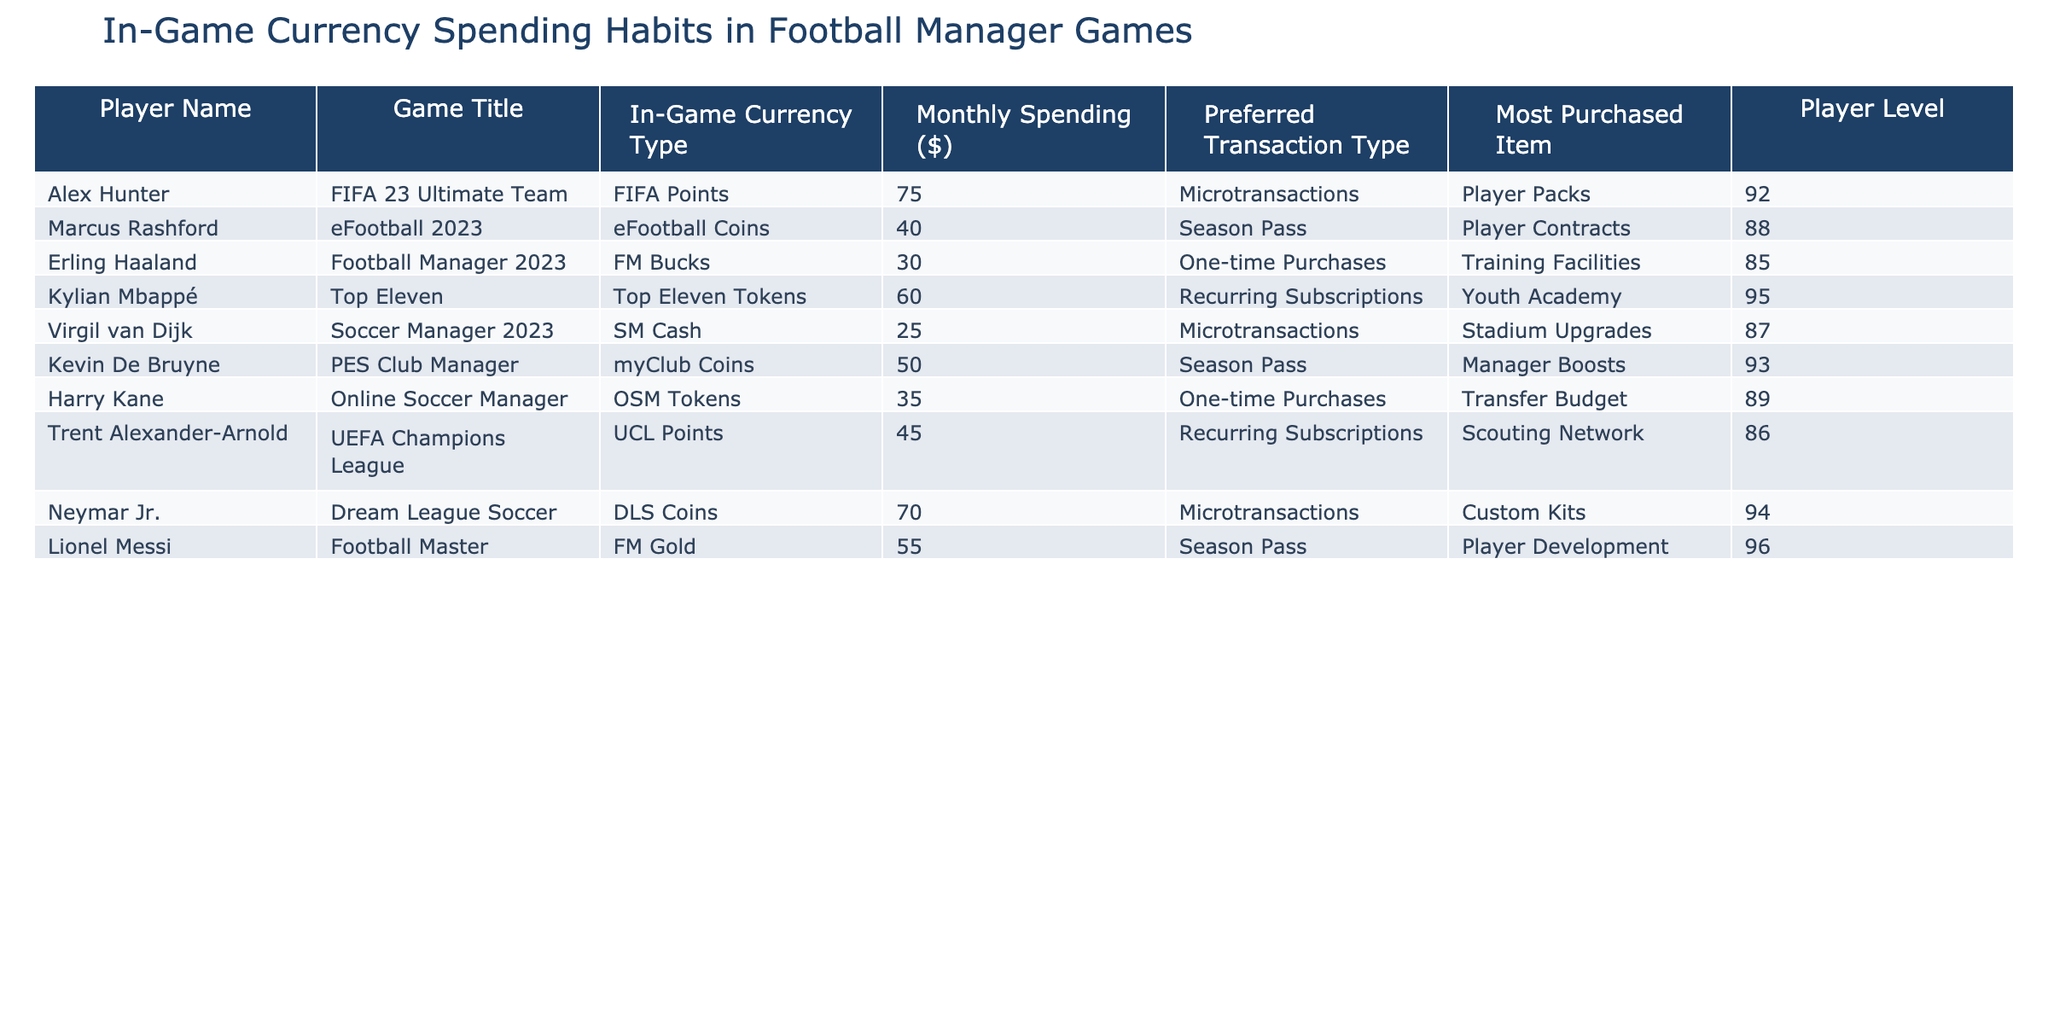What is the most purchased item by Neymar Jr.? According to the table, Neymar Jr. is noted for having the most purchased item as 'Custom Kits'.
Answer: Custom Kits Which player spends the most on in-game currency? By examining the Monthly Spending values, Alex Hunter spends the highest amount at $75.
Answer: $75 What type of transaction is most commonly preferred by Kylian Mbappé? The table indicates that Kylian Mbappé prefers 'Recurring Subscriptions' for in-game purchases.
Answer: Recurring Subscriptions Is Erling Haaland's monthly spending higher than Kevin De Bruyne's? By comparing their Monthly Spending amounts; Erling Haaland spends $30 while Kevin De Bruyne spends $50, hence not.
Answer: No What is the average monthly spending of all players listed in the table? The total spending amounts to $75 + $40 + $30 + $60 + $25 + $50 + $35 + $45 + $70 + $55 = $485. With 10 players, the average is $485 / 10 = $48.50.
Answer: $48.50 Which player has the highest player level and what is that level? The table shows that Lionel Messi has the highest player level at 96.
Answer: 96 Which transaction type is preferred by Marcus Rashford? The table specifies that Marcus Rashford prefers the 'Season Pass' transaction type for his spending.
Answer: Season Pass How much does Virgil van Dijk spend compared to Neymar Jr.? Virgil van Dijk spends $25 while Neymar Jr. spends $70; hence, Neymar Jr. spends $45 more than Virgil van Dijk.
Answer: $45 more Is any player’s preferred transaction type 'One-time Purchases'? Reviewing the table, both Erling Haaland and Harry Kane have 'One-time Purchases' as their preferred transaction type; thus, the statement is true.
Answer: Yes What is the total monthly spending of players who prefer microtransactions? The players that prefer microtransactions are Alex Hunter ($75), Virgil van Dijk ($25), and Neymar Jr. ($70). Their total spending is $75 + $25 + $70 = $170.
Answer: $170 